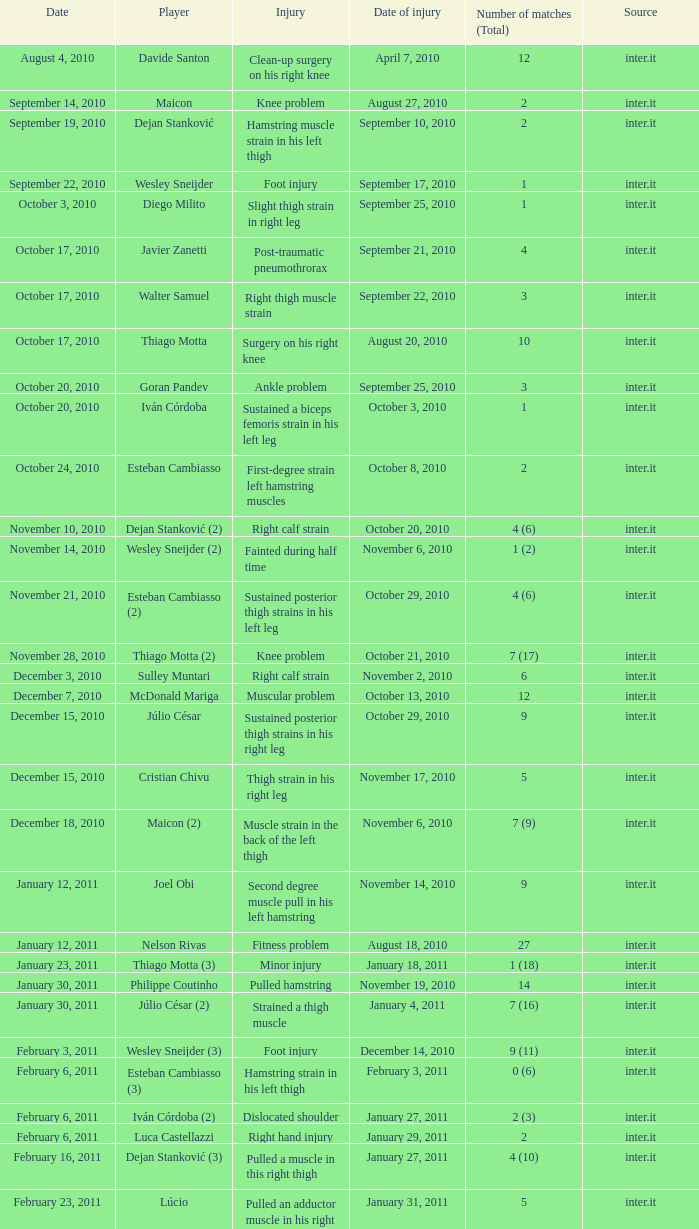If the injury is related to the foot and there is a total of one match, when did the injury occur? September 17, 2010. 